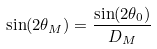<formula> <loc_0><loc_0><loc_500><loc_500>\sin ( 2 \theta _ { M } ) = \frac { \sin ( 2 \theta _ { 0 } ) } { D _ { M } }</formula> 